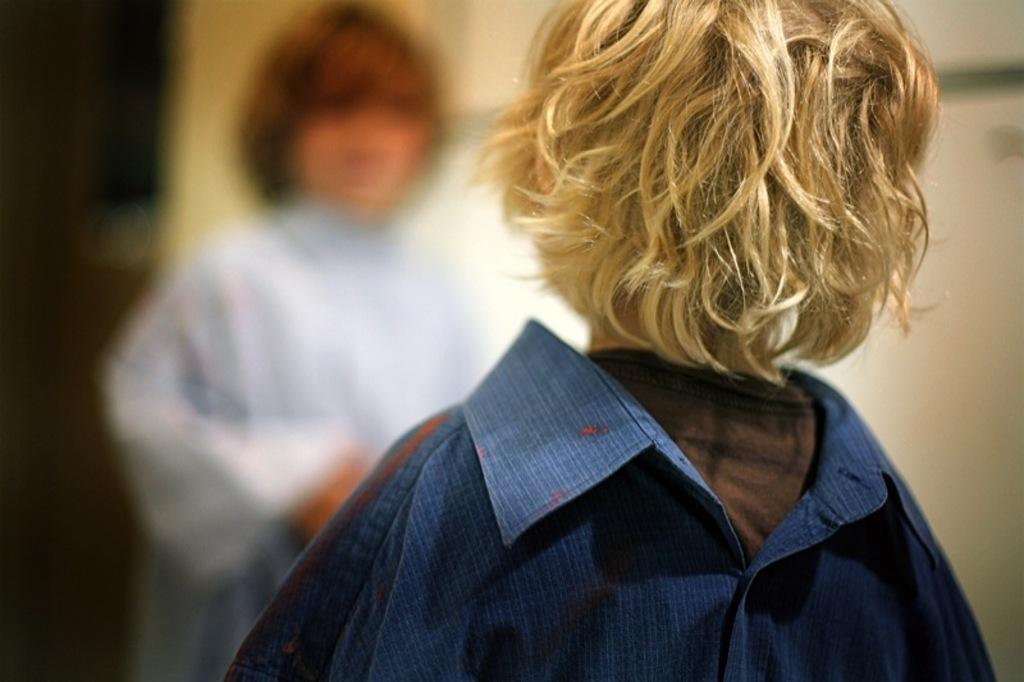How many children are present in the image? There are two kids in the image. Can you describe the background of the image? The background of the image is blurry. What type of bubble can be seen floating near the kids in the image? There is no bubble present in the image; it only features two kids and a blurry background. 